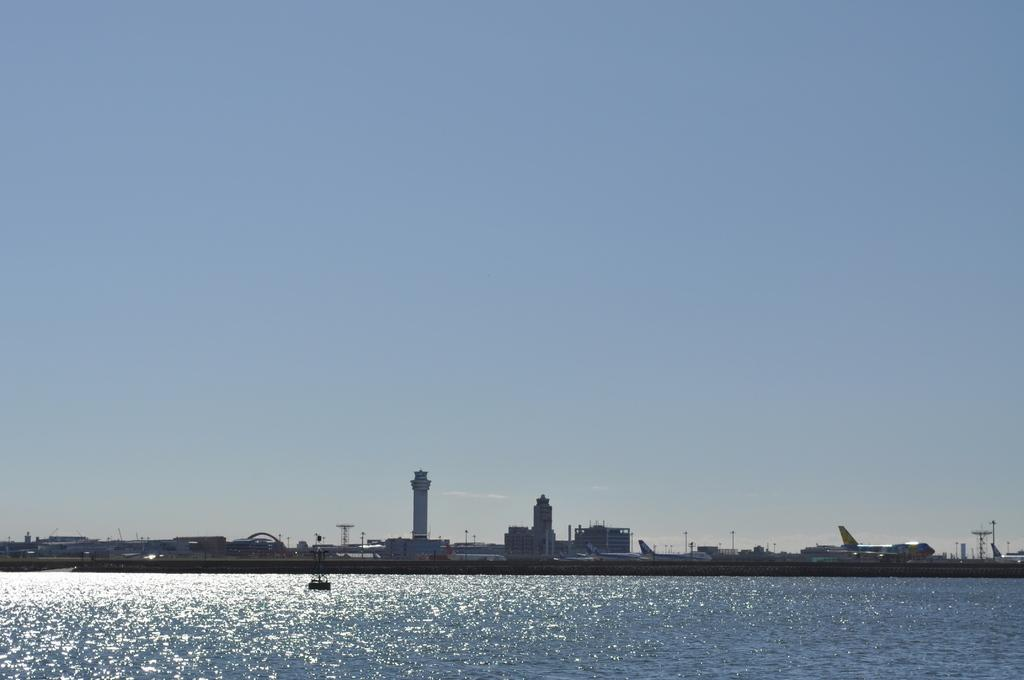What can be seen in the background of the image? In the background of the image, there are buildings, a tower, and a plane visible. What else is present in the image besides the background elements? There is also water visible in the image. Can you describe the sky in the background? The sky is visible in the background of the image. What type of glass is being used to hold the event in the image? There is no event or glass present in the image. What color is the sweater worn by the person in the image? There is no person or sweater present in the image. 